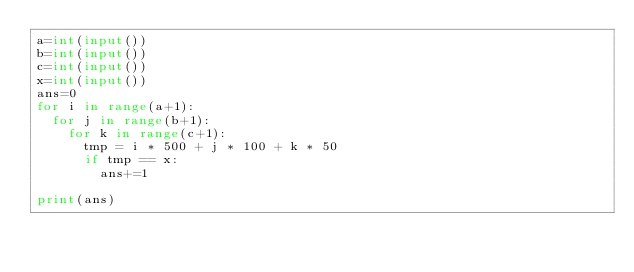<code> <loc_0><loc_0><loc_500><loc_500><_Python_>a=int(input())
b=int(input())
c=int(input())
x=int(input())
ans=0
for i in range(a+1):
  for j in range(b+1):
    for k in range(c+1):
      tmp = i * 500 + j * 100 + k * 50
      if tmp == x:
        ans+=1

print(ans)</code> 